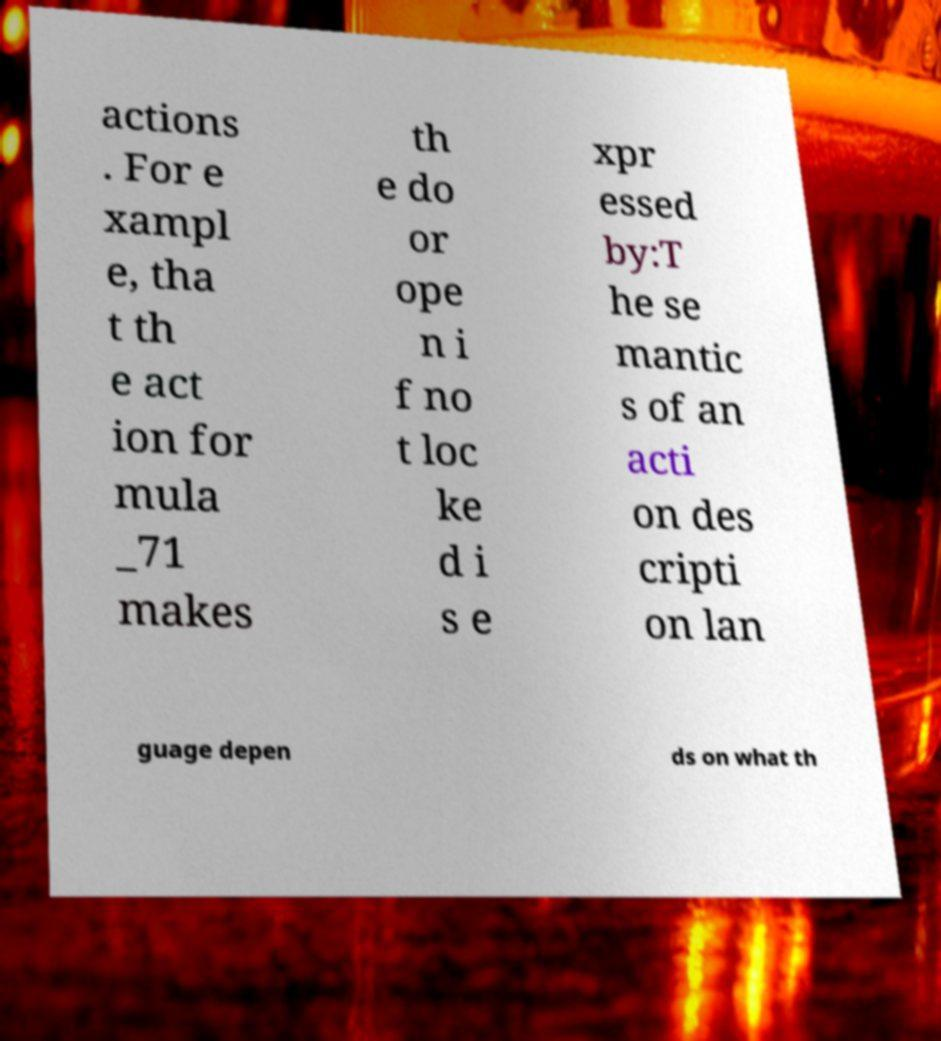I need the written content from this picture converted into text. Can you do that? actions . For e xampl e, tha t th e act ion for mula _71 makes th e do or ope n i f no t loc ke d i s e xpr essed by:T he se mantic s of an acti on des cripti on lan guage depen ds on what th 